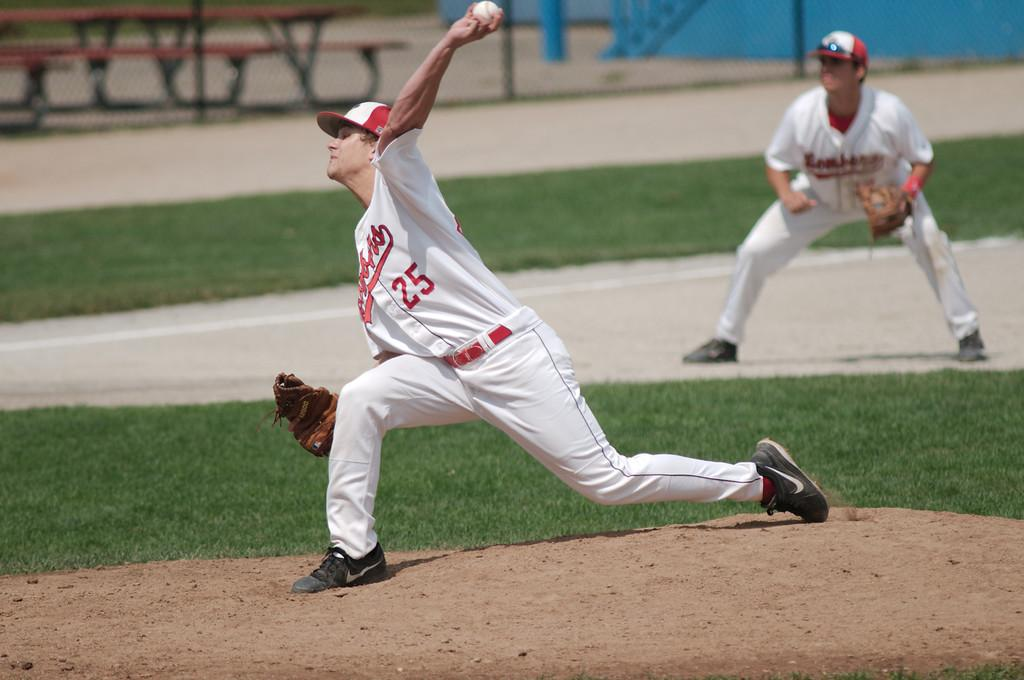<image>
Summarize the visual content of the image. A baseball player throwing a ball with the number 25 on his white jersey. 